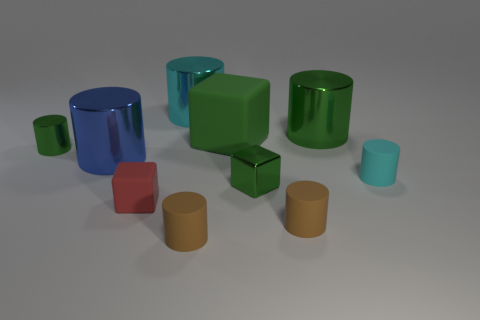There is a big block that is the same color as the small shiny block; what is its material?
Make the answer very short. Rubber. There is a large thing right of the large green matte cube; does it have the same color as the small object that is to the left of the red matte cube?
Give a very brief answer. Yes. How many things are either cyan cubes or green shiny cylinders?
Provide a succinct answer. 2. What number of other things are there of the same shape as the tiny cyan thing?
Give a very brief answer. 6. Is the material of the green cylinder that is to the left of the red block the same as the brown object that is on the right side of the green rubber block?
Your answer should be very brief. No. There is a tiny thing that is both to the left of the cyan shiny cylinder and in front of the small cyan cylinder; what is its shape?
Your answer should be very brief. Cube. The large thing that is both in front of the big green metallic object and behind the large blue shiny object is made of what material?
Provide a succinct answer. Rubber. What shape is the cyan object that is made of the same material as the tiny green cube?
Keep it short and to the point. Cylinder. Are there any other things of the same color as the tiny rubber block?
Offer a very short reply. No. Is the number of big cubes that are to the right of the big cyan shiny cylinder greater than the number of purple matte things?
Give a very brief answer. Yes. 